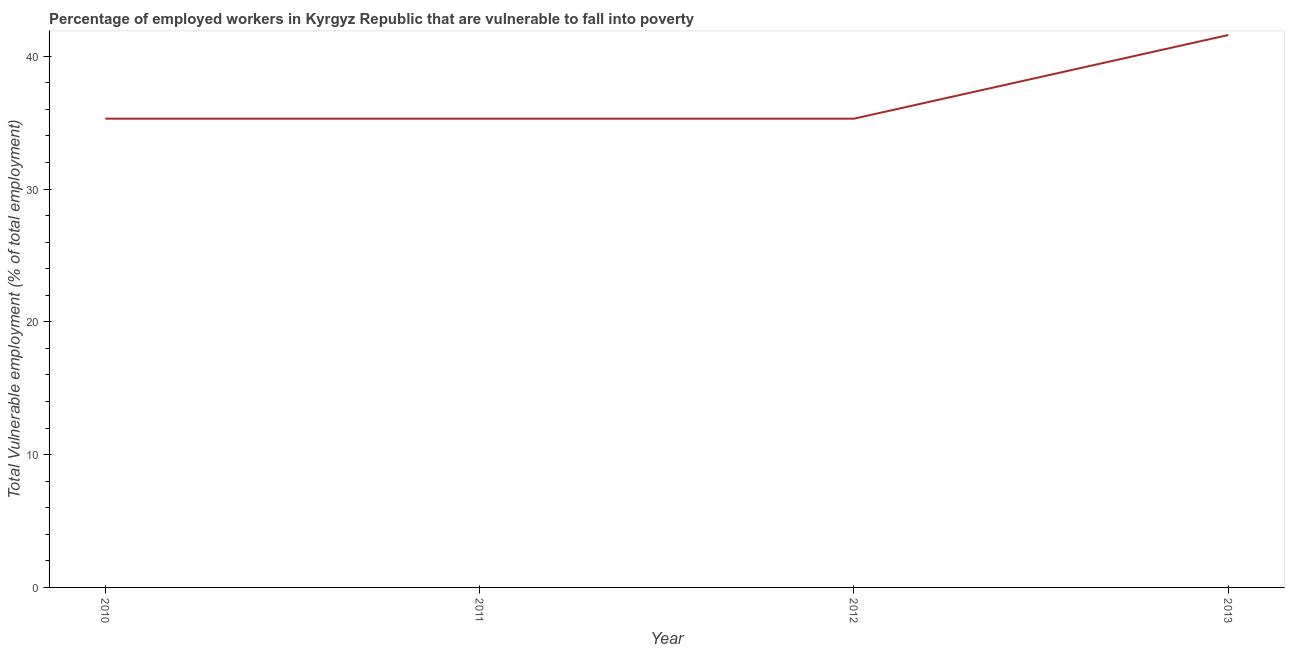What is the total vulnerable employment in 2012?
Provide a short and direct response. 35.3. Across all years, what is the maximum total vulnerable employment?
Keep it short and to the point. 41.6. Across all years, what is the minimum total vulnerable employment?
Offer a terse response. 35.3. In which year was the total vulnerable employment maximum?
Offer a very short reply. 2013. What is the sum of the total vulnerable employment?
Your response must be concise. 147.5. What is the average total vulnerable employment per year?
Offer a very short reply. 36.87. What is the median total vulnerable employment?
Your answer should be compact. 35.3. In how many years, is the total vulnerable employment greater than 38 %?
Provide a short and direct response. 1. Do a majority of the years between 2011 and 2012 (inclusive) have total vulnerable employment greater than 28 %?
Your answer should be very brief. Yes. What is the ratio of the total vulnerable employment in 2011 to that in 2013?
Offer a terse response. 0.85. Is the difference between the total vulnerable employment in 2012 and 2013 greater than the difference between any two years?
Your answer should be very brief. Yes. What is the difference between the highest and the second highest total vulnerable employment?
Offer a very short reply. 6.3. Is the sum of the total vulnerable employment in 2010 and 2013 greater than the maximum total vulnerable employment across all years?
Your answer should be very brief. Yes. What is the difference between the highest and the lowest total vulnerable employment?
Your answer should be very brief. 6.3. In how many years, is the total vulnerable employment greater than the average total vulnerable employment taken over all years?
Ensure brevity in your answer.  1. Does the total vulnerable employment monotonically increase over the years?
Your answer should be very brief. No. What is the difference between two consecutive major ticks on the Y-axis?
Make the answer very short. 10. What is the title of the graph?
Give a very brief answer. Percentage of employed workers in Kyrgyz Republic that are vulnerable to fall into poverty. What is the label or title of the Y-axis?
Your answer should be very brief. Total Vulnerable employment (% of total employment). What is the Total Vulnerable employment (% of total employment) in 2010?
Offer a terse response. 35.3. What is the Total Vulnerable employment (% of total employment) in 2011?
Offer a terse response. 35.3. What is the Total Vulnerable employment (% of total employment) of 2012?
Provide a short and direct response. 35.3. What is the Total Vulnerable employment (% of total employment) in 2013?
Offer a very short reply. 41.6. What is the difference between the Total Vulnerable employment (% of total employment) in 2010 and 2012?
Offer a very short reply. 0. What is the difference between the Total Vulnerable employment (% of total employment) in 2012 and 2013?
Offer a terse response. -6.3. What is the ratio of the Total Vulnerable employment (% of total employment) in 2010 to that in 2011?
Offer a terse response. 1. What is the ratio of the Total Vulnerable employment (% of total employment) in 2010 to that in 2012?
Offer a very short reply. 1. What is the ratio of the Total Vulnerable employment (% of total employment) in 2010 to that in 2013?
Provide a short and direct response. 0.85. What is the ratio of the Total Vulnerable employment (% of total employment) in 2011 to that in 2012?
Give a very brief answer. 1. What is the ratio of the Total Vulnerable employment (% of total employment) in 2011 to that in 2013?
Provide a succinct answer. 0.85. What is the ratio of the Total Vulnerable employment (% of total employment) in 2012 to that in 2013?
Your response must be concise. 0.85. 